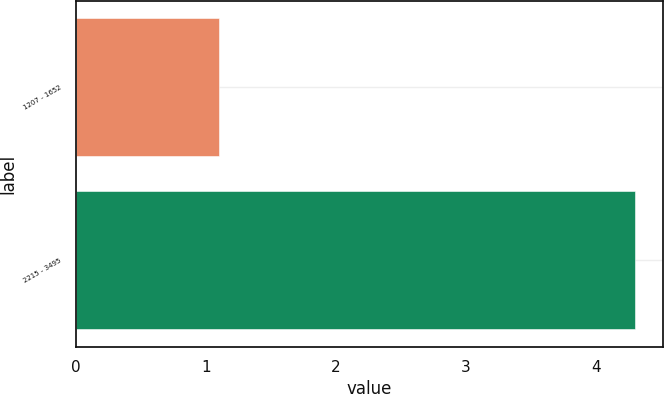Convert chart. <chart><loc_0><loc_0><loc_500><loc_500><bar_chart><fcel>1207 - 1652<fcel>2215 - 3495<nl><fcel>1.1<fcel>4.3<nl></chart> 